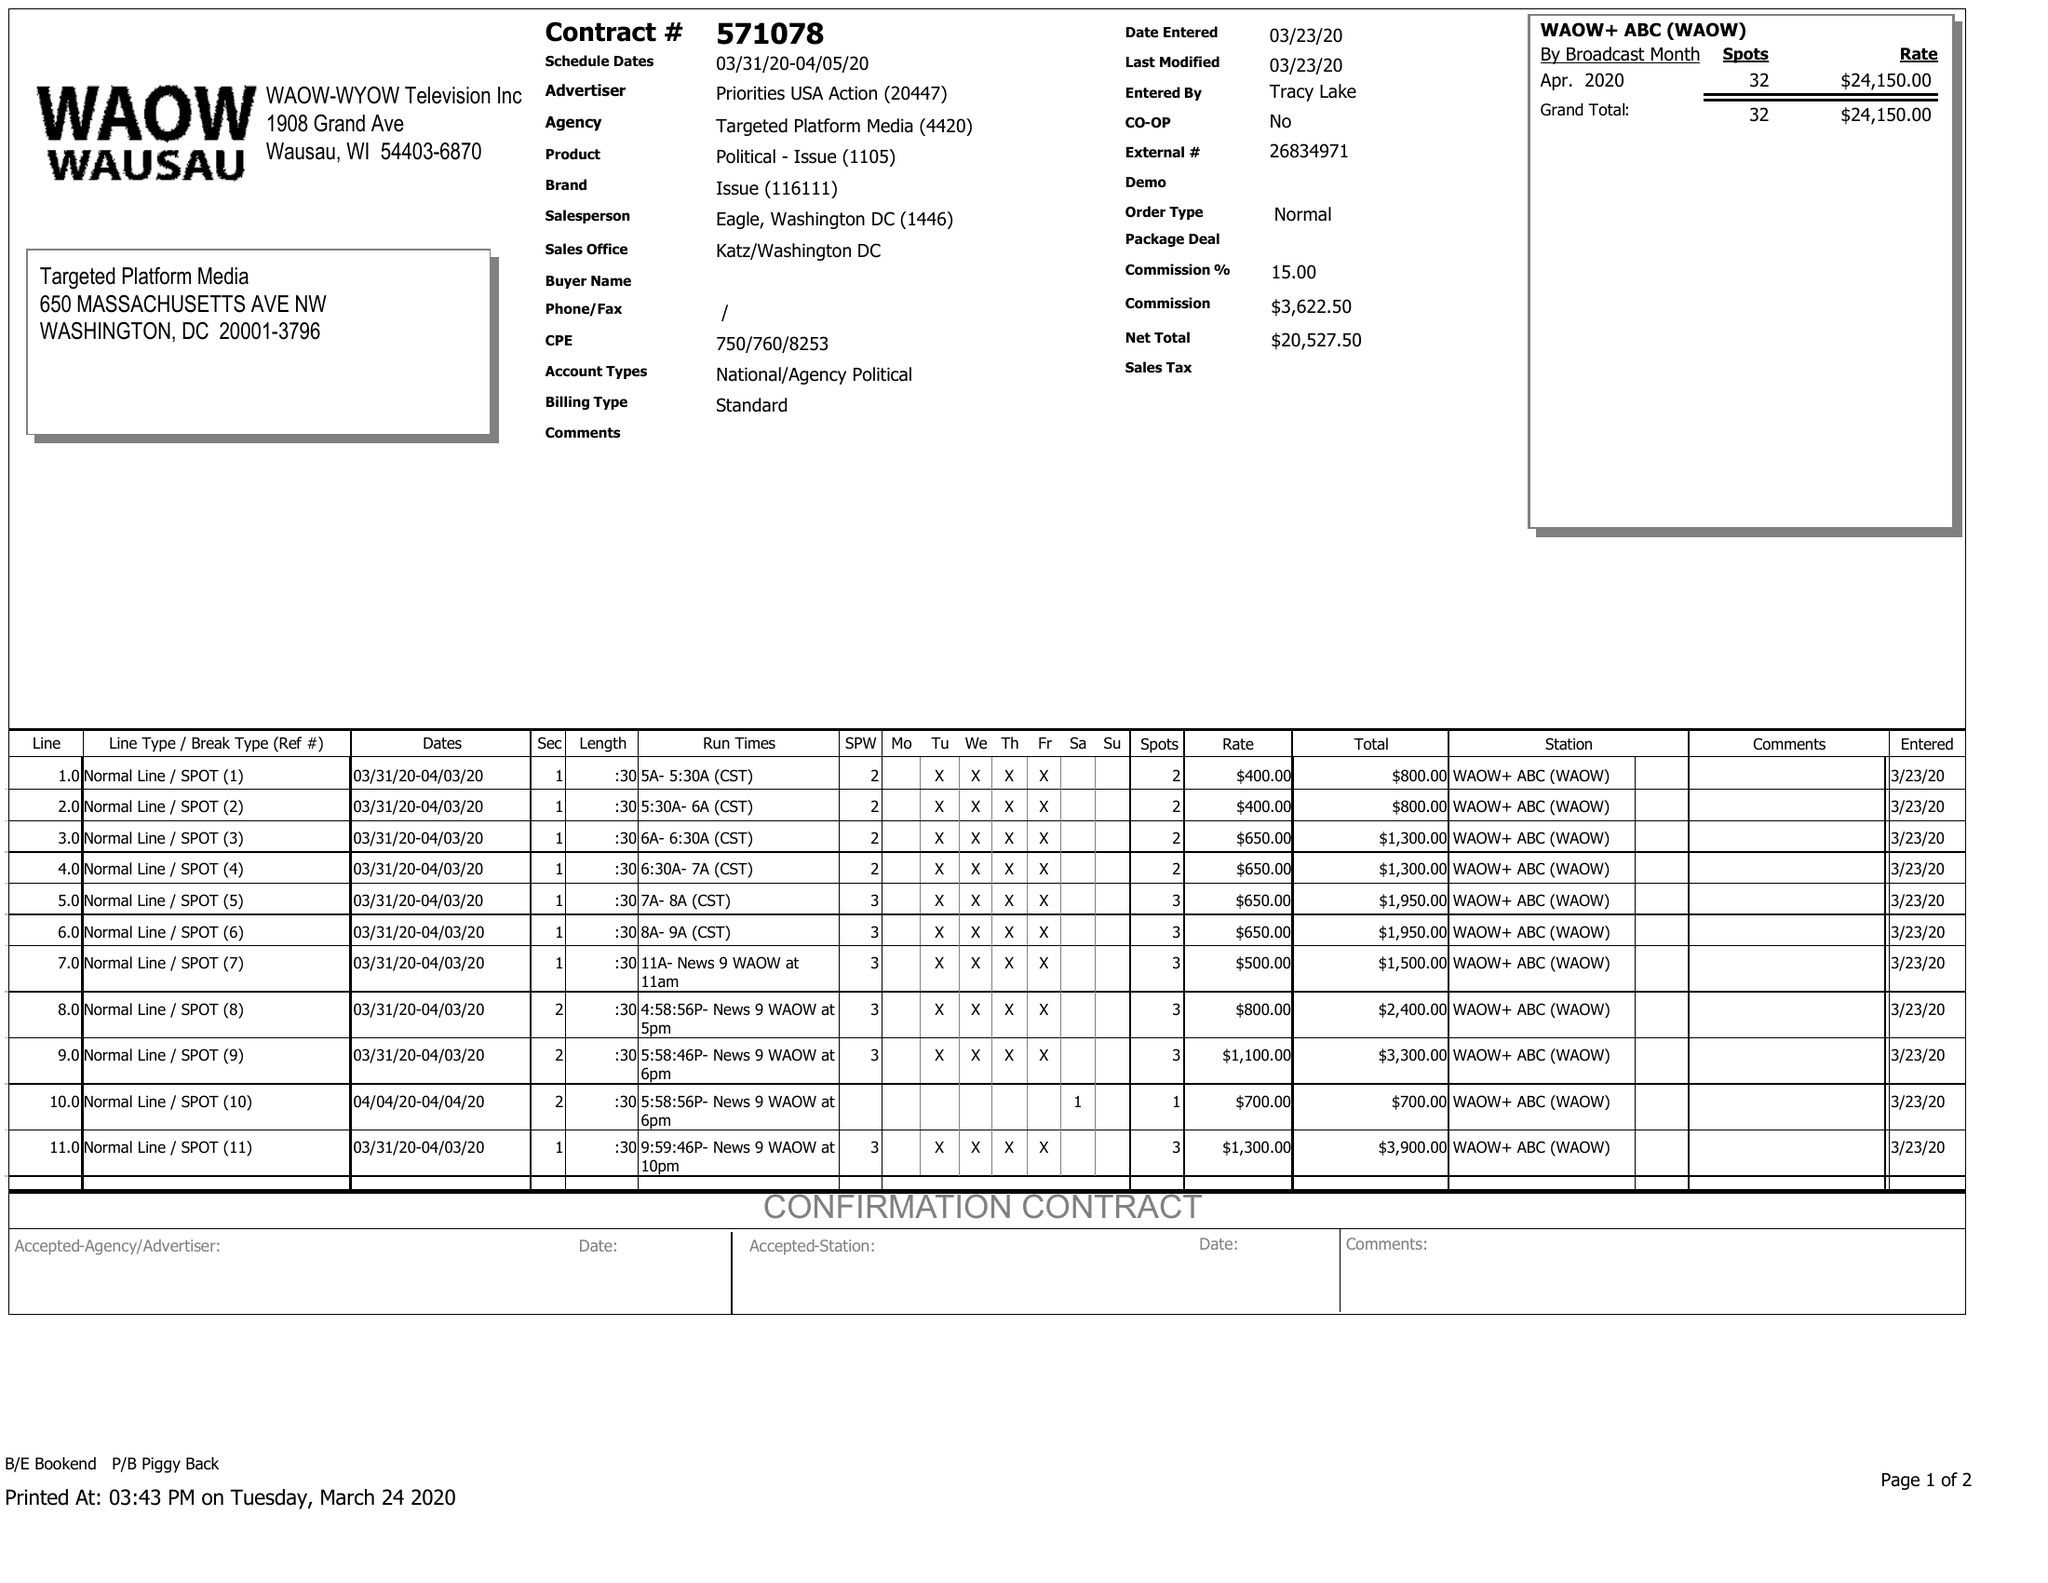What is the value for the flight_from?
Answer the question using a single word or phrase. 03/31/20 